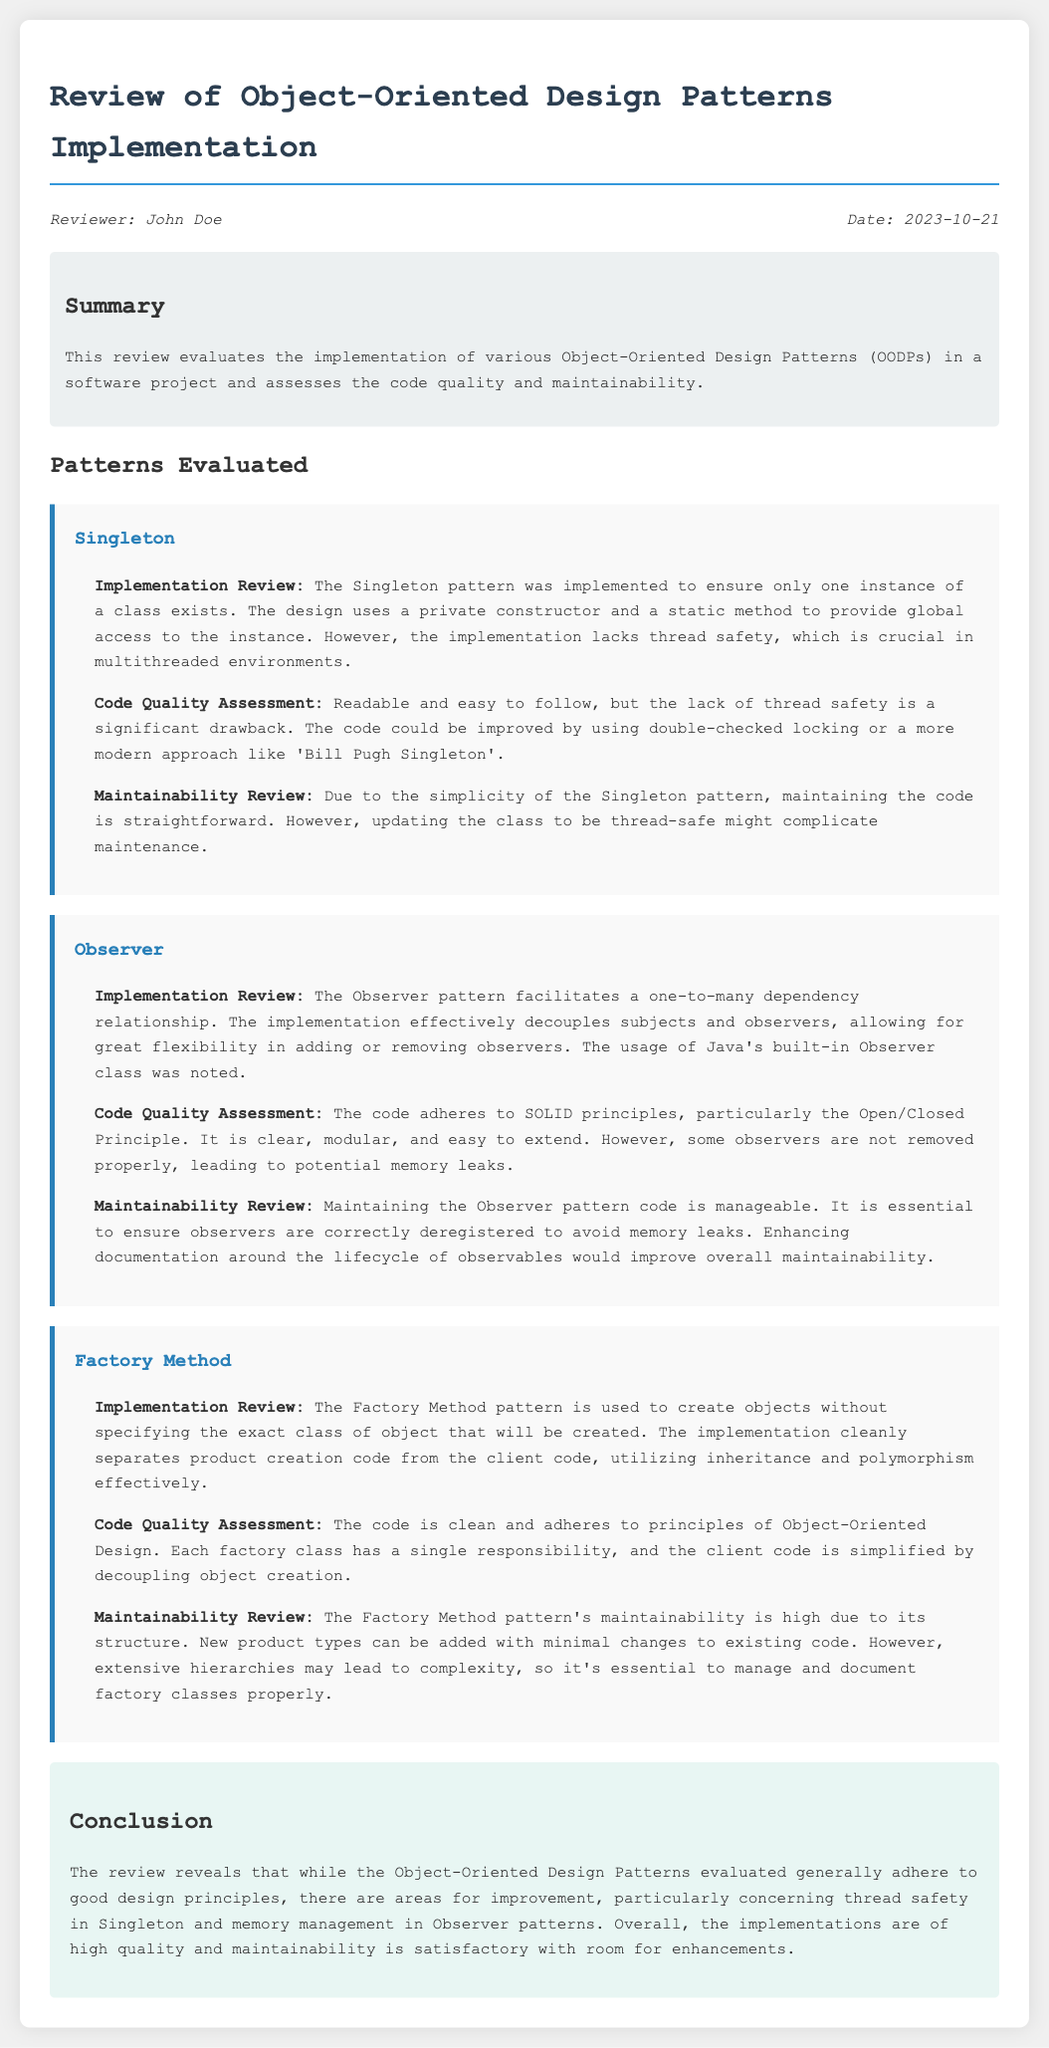What is the review date? The review date is mentioned in the meta-info section of the document.
Answer: 2023-10-21 Who is the reviewer? The reviewer's name is provided in the meta-info section at the top of the document.
Answer: John Doe What is the main focus of the review? The summary section outlines that the review evaluates OODPs and assesses code quality and maintainability.
Answer: Object-Oriented Design Patterns implementation What pattern lacks thread safety? The implementation review section mentions a specific pattern that has thread safety issues.
Answer: Singleton Which pattern effectively decouples subjects and observers? The implementation review section describes a pattern that maintains a one-to-many dependency relationship.
Answer: Observer What principle does the Observer pattern adhere to? The code quality assessment for the Observer pattern indicates which principle it follows.
Answer: Open/Closed Principle What aspect could complicate maintenance of the Singleton pattern? The maintainability review highlights a potential complication in the Singleton pattern.
Answer: Thread safety How is the Factory Method pattern’s maintainability described? The maintainability review for the Factory Method pattern offers a specific quality level.
Answer: High What area needs enhancement in the Observer pattern? The maintainability review suggests an improvement for better memory management in the Observer pattern.
Answer: Documentation of observers' lifecycle 